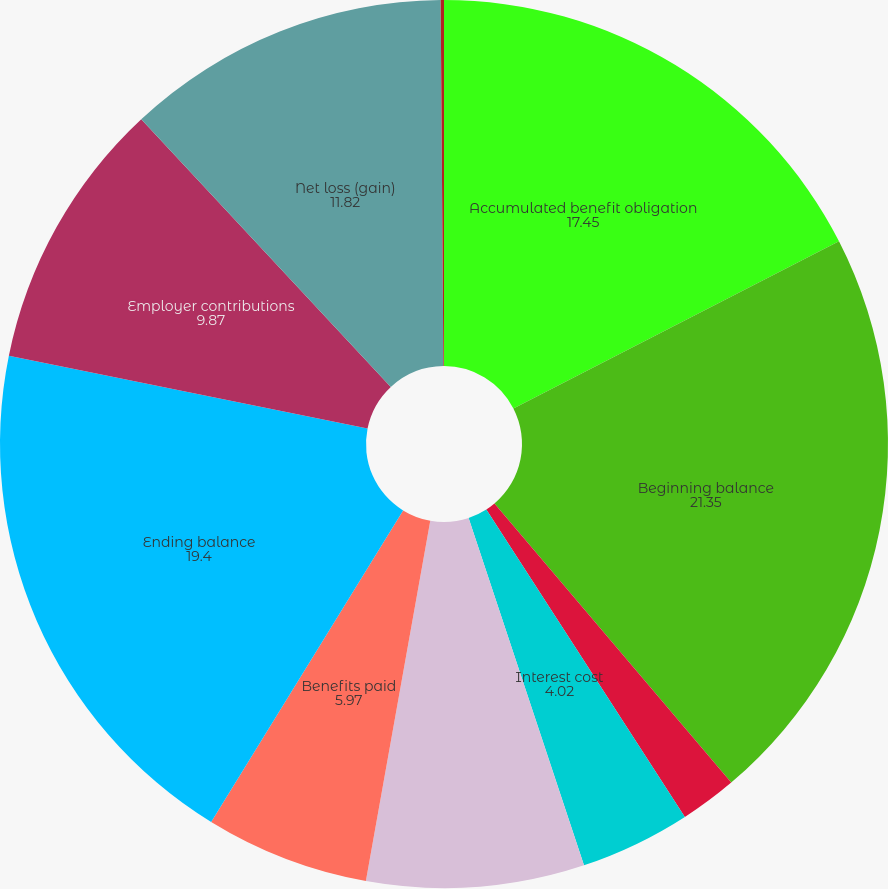Convert chart to OTSL. <chart><loc_0><loc_0><loc_500><loc_500><pie_chart><fcel>Accumulated benefit obligation<fcel>Beginning balance<fcel>Service cost<fcel>Interest cost<fcel>Actuarial loss (gain) (b)<fcel>Benefits paid<fcel>Ending balance<fcel>Employer contributions<fcel>Net loss (gain)<fcel>Prior service cost (credit)<nl><fcel>17.45%<fcel>21.35%<fcel>2.07%<fcel>4.02%<fcel>7.92%<fcel>5.97%<fcel>19.4%<fcel>9.87%<fcel>11.82%<fcel>0.12%<nl></chart> 